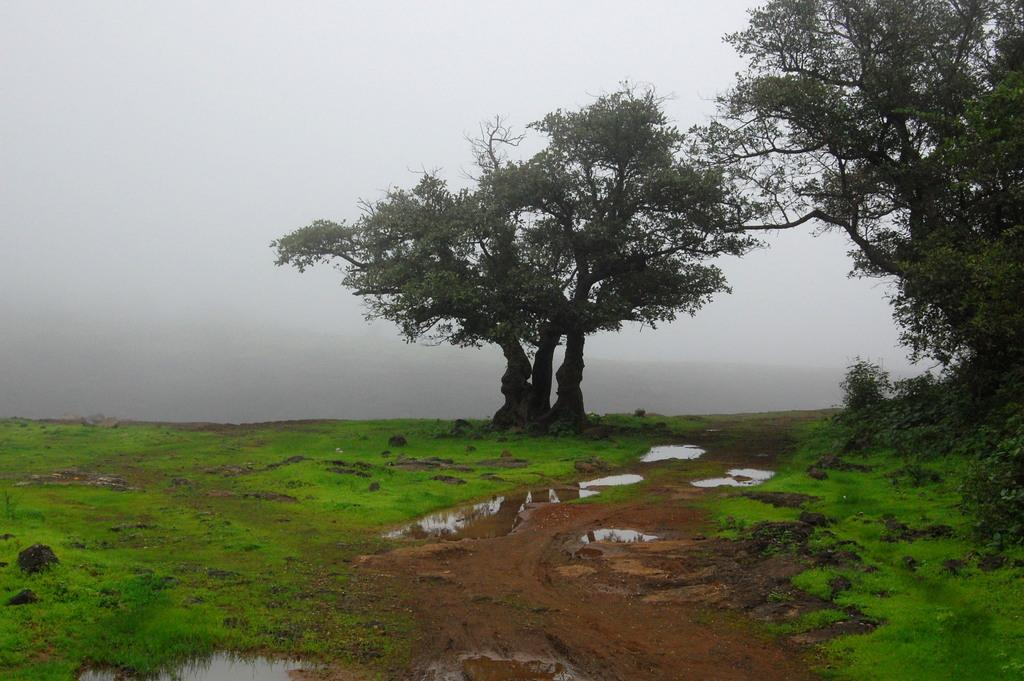What type of terrain is visible in the image? There is ground visible in the image. What is on the ground in the image? There is water on the ground in the image. What type of vegetation can be seen in the image? There is grass, trees, and plants in the image. What part of the natural environment is visible in the image? The sky is visible in the image. How many turkeys are visible in the image? There are no turkeys present in the image. What type of knot is used to tie the plants together in the image? There is no knot used to tie the plants together in the image, as they are not tied. 